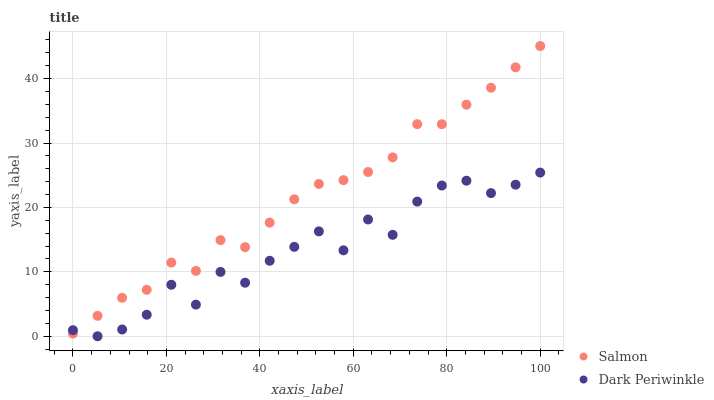Does Dark Periwinkle have the minimum area under the curve?
Answer yes or no. Yes. Does Salmon have the maximum area under the curve?
Answer yes or no. Yes. Does Dark Periwinkle have the maximum area under the curve?
Answer yes or no. No. Is Salmon the smoothest?
Answer yes or no. Yes. Is Dark Periwinkle the roughest?
Answer yes or no. Yes. Is Dark Periwinkle the smoothest?
Answer yes or no. No. Does Dark Periwinkle have the lowest value?
Answer yes or no. Yes. Does Salmon have the highest value?
Answer yes or no. Yes. Does Dark Periwinkle have the highest value?
Answer yes or no. No. Does Dark Periwinkle intersect Salmon?
Answer yes or no. Yes. Is Dark Periwinkle less than Salmon?
Answer yes or no. No. Is Dark Periwinkle greater than Salmon?
Answer yes or no. No. 